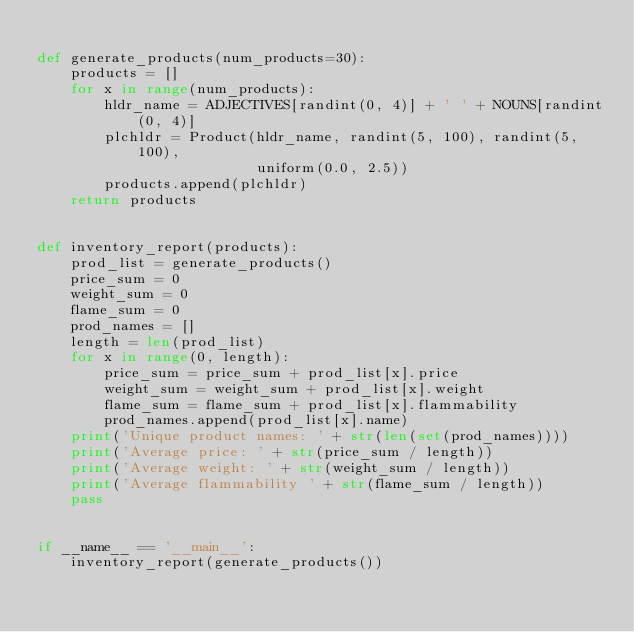<code> <loc_0><loc_0><loc_500><loc_500><_Python_>
def generate_products(num_products=30):
    products = []
    for x in range(num_products):
        hldr_name = ADJECTIVES[randint(0, 4)] + ' ' + NOUNS[randint(0, 4)]
        plchldr = Product(hldr_name, randint(5, 100), randint(5, 100),
                          uniform(0.0, 2.5))
        products.append(plchldr)
    return products


def inventory_report(products):
    prod_list = generate_products()
    price_sum = 0
    weight_sum = 0
    flame_sum = 0
    prod_names = []
    length = len(prod_list)
    for x in range(0, length):
        price_sum = price_sum + prod_list[x].price
        weight_sum = weight_sum + prod_list[x].weight
        flame_sum = flame_sum + prod_list[x].flammability
        prod_names.append(prod_list[x].name)
    print('Unique product names: ' + str(len(set(prod_names))))
    print('Average price: ' + str(price_sum / length))
    print('Average weight: ' + str(weight_sum / length))
    print('Average flammability ' + str(flame_sum / length))
    pass


if __name__ == '__main__':
    inventory_report(generate_products())
</code> 